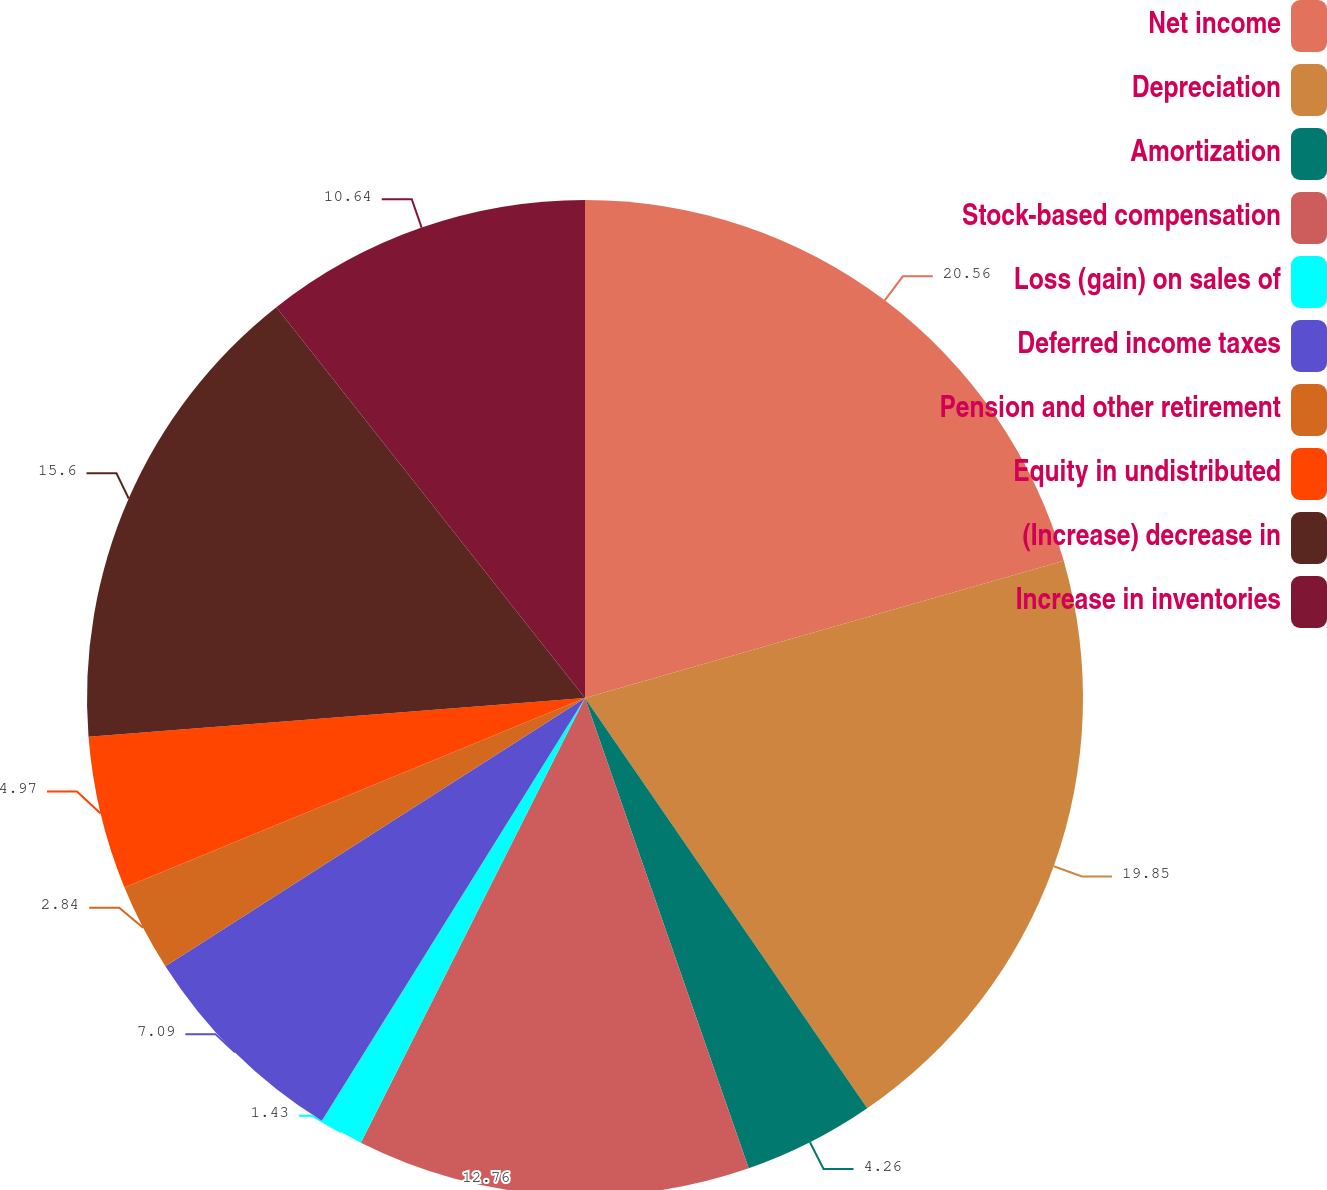Convert chart. <chart><loc_0><loc_0><loc_500><loc_500><pie_chart><fcel>Net income<fcel>Depreciation<fcel>Amortization<fcel>Stock-based compensation<fcel>Loss (gain) on sales of<fcel>Deferred income taxes<fcel>Pension and other retirement<fcel>Equity in undistributed<fcel>(Increase) decrease in<fcel>Increase in inventories<nl><fcel>20.56%<fcel>19.85%<fcel>4.26%<fcel>12.76%<fcel>1.43%<fcel>7.09%<fcel>2.84%<fcel>4.97%<fcel>15.6%<fcel>10.64%<nl></chart> 